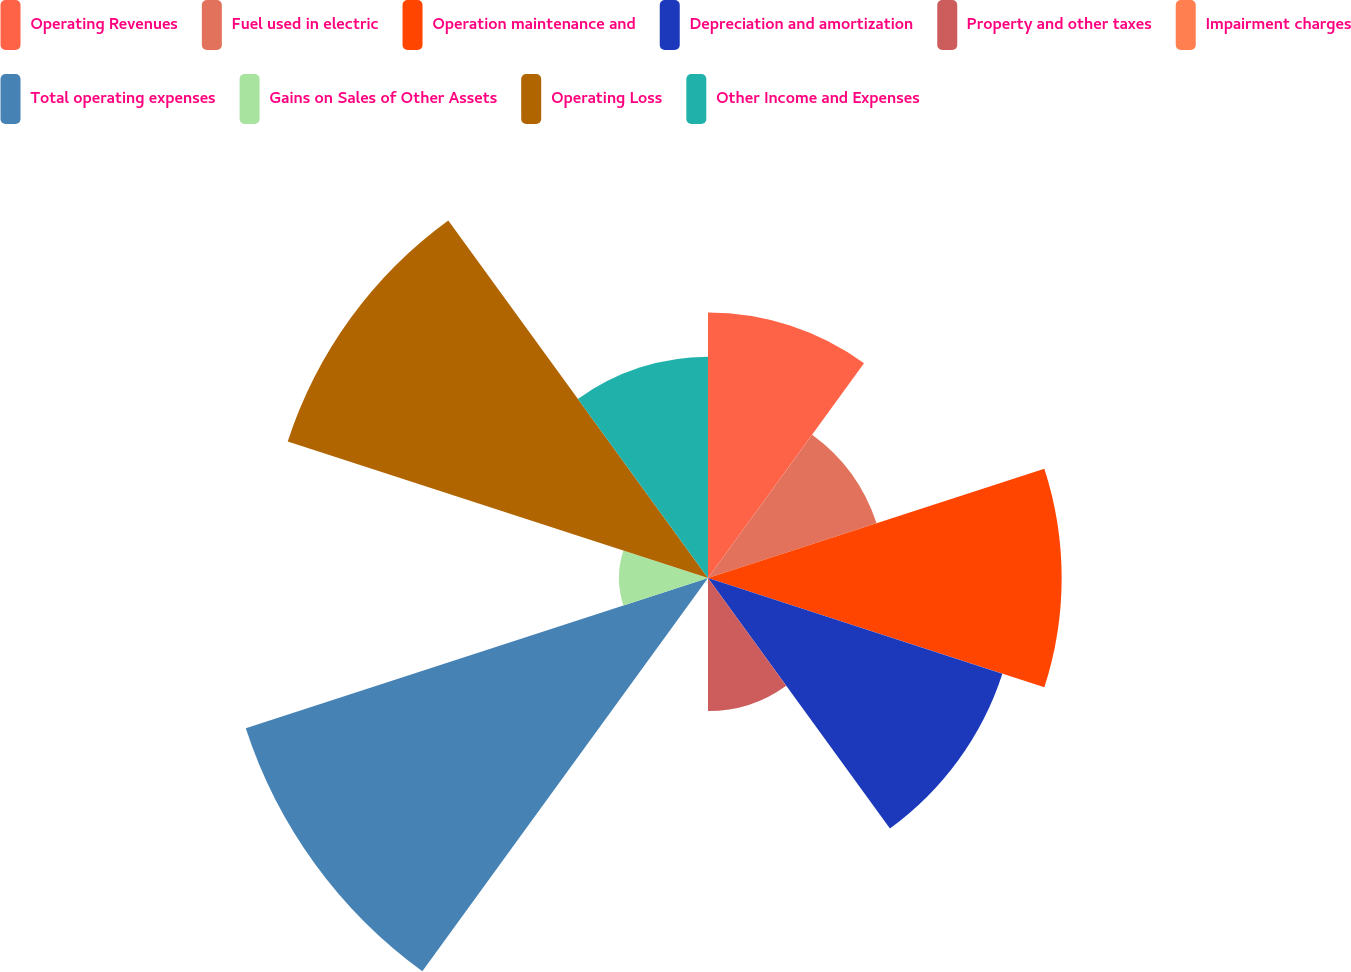Convert chart to OTSL. <chart><loc_0><loc_0><loc_500><loc_500><pie_chart><fcel>Operating Revenues<fcel>Fuel used in electric<fcel>Operation maintenance and<fcel>Depreciation and amortization<fcel>Property and other taxes<fcel>Impairment charges<fcel>Total operating expenses<fcel>Gains on Sales of Other Assets<fcel>Operating Loss<fcel>Other Income and Expenses<nl><fcel>10.71%<fcel>7.15%<fcel>14.27%<fcel>12.49%<fcel>5.37%<fcel>0.03%<fcel>19.61%<fcel>3.59%<fcel>17.83%<fcel>8.93%<nl></chart> 